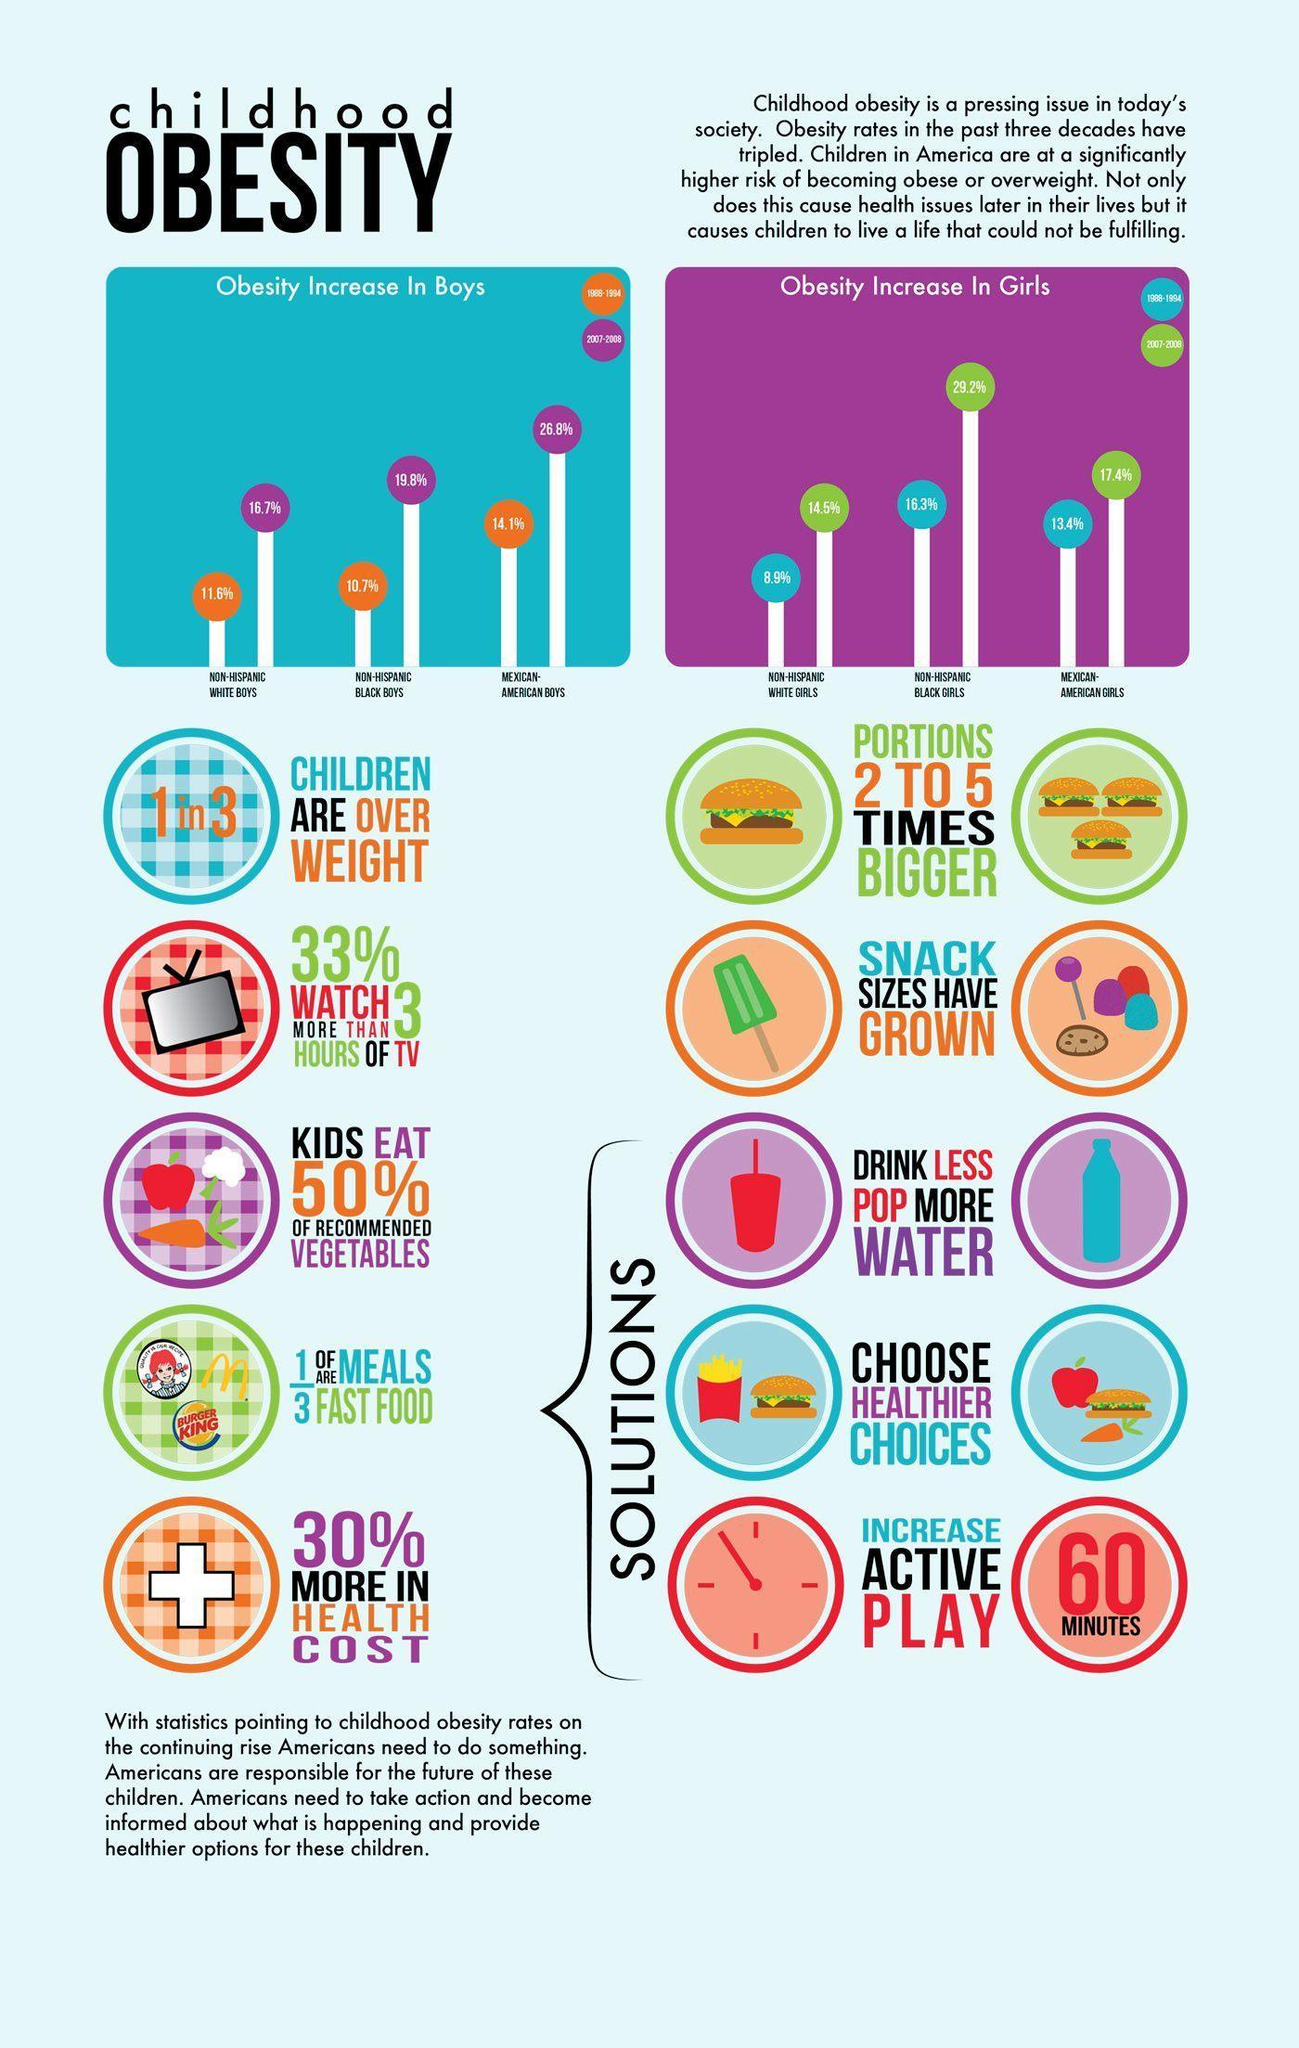What is the percentage increase of Obesity in Mexican American boys during 1988-1994?
Answer the question with a short phrase. 14.1% What is the percentage increase of Obesity in Non-hispanic black girls in America during 2007-2008? 29.2% What is the percentage increase of Obesity in Non-hispanic black boys in America during 2007-2008? 19.8% How many minutes of physical activity is recommended as a solution for obesity? 60 MINUTES During which time span, the obesity increase of 16.3% were observed in Non-hispanic black girls? 1988-1994 During which year, the obesity increase of 26.8% were observed in Mexican American boys? 2007-2008 What is the percentage increase of Obesity in Non-hispanic White girls in America during 2007-2008? 14.5% 